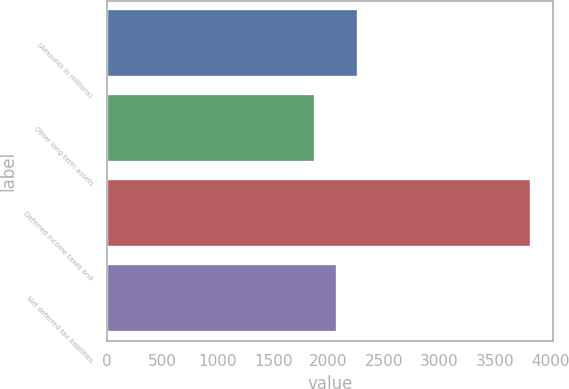<chart> <loc_0><loc_0><loc_500><loc_500><bar_chart><fcel>(Amounts in millions)<fcel>Other long-term assets<fcel>Deferred income taxes and<fcel>Net deferred tax liabilities<nl><fcel>2269.4<fcel>1879<fcel>3831<fcel>2074.2<nl></chart> 